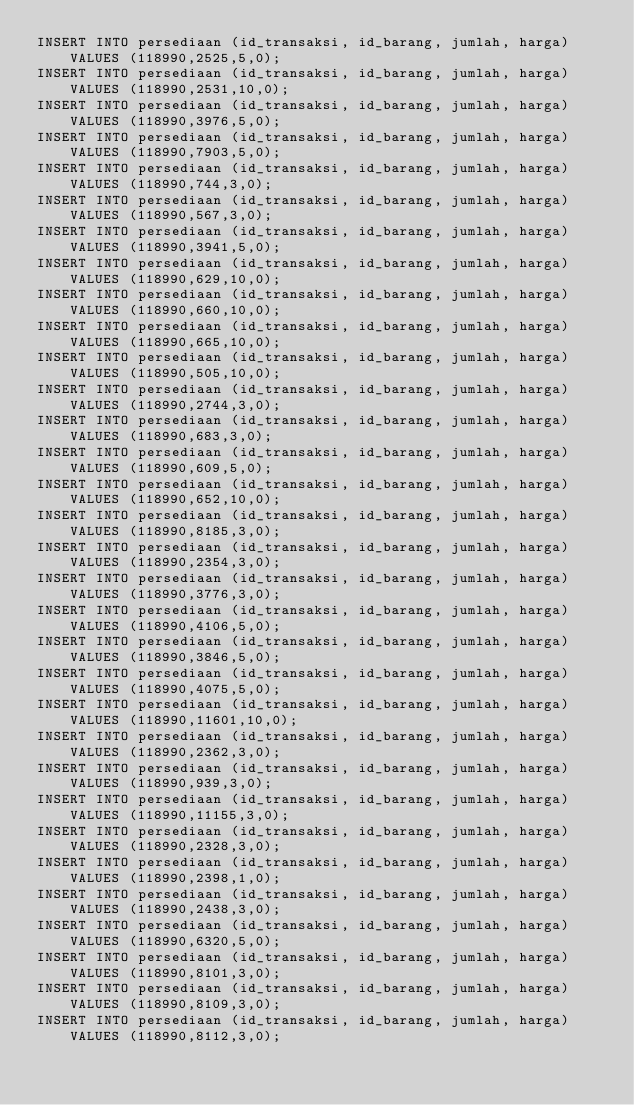<code> <loc_0><loc_0><loc_500><loc_500><_SQL_>INSERT INTO persediaan (id_transaksi, id_barang, jumlah, harga) VALUES (118990,2525,5,0);
INSERT INTO persediaan (id_transaksi, id_barang, jumlah, harga) VALUES (118990,2531,10,0);
INSERT INTO persediaan (id_transaksi, id_barang, jumlah, harga) VALUES (118990,3976,5,0);
INSERT INTO persediaan (id_transaksi, id_barang, jumlah, harga) VALUES (118990,7903,5,0);
INSERT INTO persediaan (id_transaksi, id_barang, jumlah, harga) VALUES (118990,744,3,0);
INSERT INTO persediaan (id_transaksi, id_barang, jumlah, harga) VALUES (118990,567,3,0);
INSERT INTO persediaan (id_transaksi, id_barang, jumlah, harga) VALUES (118990,3941,5,0);
INSERT INTO persediaan (id_transaksi, id_barang, jumlah, harga) VALUES (118990,629,10,0);
INSERT INTO persediaan (id_transaksi, id_barang, jumlah, harga) VALUES (118990,660,10,0);
INSERT INTO persediaan (id_transaksi, id_barang, jumlah, harga) VALUES (118990,665,10,0);
INSERT INTO persediaan (id_transaksi, id_barang, jumlah, harga) VALUES (118990,505,10,0);
INSERT INTO persediaan (id_transaksi, id_barang, jumlah, harga) VALUES (118990,2744,3,0);
INSERT INTO persediaan (id_transaksi, id_barang, jumlah, harga) VALUES (118990,683,3,0);
INSERT INTO persediaan (id_transaksi, id_barang, jumlah, harga) VALUES (118990,609,5,0);
INSERT INTO persediaan (id_transaksi, id_barang, jumlah, harga) VALUES (118990,652,10,0);
INSERT INTO persediaan (id_transaksi, id_barang, jumlah, harga) VALUES (118990,8185,3,0);
INSERT INTO persediaan (id_transaksi, id_barang, jumlah, harga) VALUES (118990,2354,3,0);
INSERT INTO persediaan (id_transaksi, id_barang, jumlah, harga) VALUES (118990,3776,3,0);
INSERT INTO persediaan (id_transaksi, id_barang, jumlah, harga) VALUES (118990,4106,5,0);
INSERT INTO persediaan (id_transaksi, id_barang, jumlah, harga) VALUES (118990,3846,5,0);
INSERT INTO persediaan (id_transaksi, id_barang, jumlah, harga) VALUES (118990,4075,5,0);
INSERT INTO persediaan (id_transaksi, id_barang, jumlah, harga) VALUES (118990,11601,10,0);
INSERT INTO persediaan (id_transaksi, id_barang, jumlah, harga) VALUES (118990,2362,3,0);
INSERT INTO persediaan (id_transaksi, id_barang, jumlah, harga) VALUES (118990,939,3,0);
INSERT INTO persediaan (id_transaksi, id_barang, jumlah, harga) VALUES (118990,11155,3,0);
INSERT INTO persediaan (id_transaksi, id_barang, jumlah, harga) VALUES (118990,2328,3,0);
INSERT INTO persediaan (id_transaksi, id_barang, jumlah, harga) VALUES (118990,2398,1,0);
INSERT INTO persediaan (id_transaksi, id_barang, jumlah, harga) VALUES (118990,2438,3,0);
INSERT INTO persediaan (id_transaksi, id_barang, jumlah, harga) VALUES (118990,6320,5,0);
INSERT INTO persediaan (id_transaksi, id_barang, jumlah, harga) VALUES (118990,8101,3,0);
INSERT INTO persediaan (id_transaksi, id_barang, jumlah, harga) VALUES (118990,8109,3,0);
INSERT INTO persediaan (id_transaksi, id_barang, jumlah, harga) VALUES (118990,8112,3,0);
</code> 